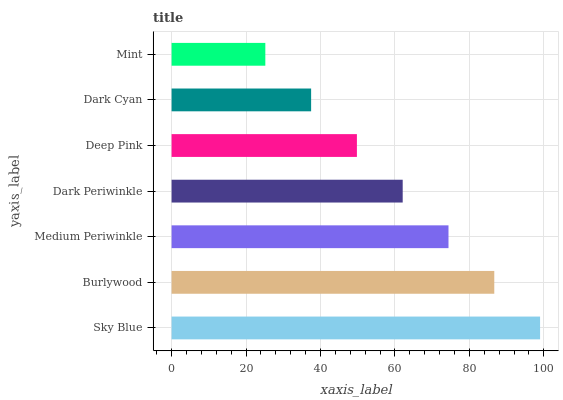Is Mint the minimum?
Answer yes or no. Yes. Is Sky Blue the maximum?
Answer yes or no. Yes. Is Burlywood the minimum?
Answer yes or no. No. Is Burlywood the maximum?
Answer yes or no. No. Is Sky Blue greater than Burlywood?
Answer yes or no. Yes. Is Burlywood less than Sky Blue?
Answer yes or no. Yes. Is Burlywood greater than Sky Blue?
Answer yes or no. No. Is Sky Blue less than Burlywood?
Answer yes or no. No. Is Dark Periwinkle the high median?
Answer yes or no. Yes. Is Dark Periwinkle the low median?
Answer yes or no. Yes. Is Sky Blue the high median?
Answer yes or no. No. Is Medium Periwinkle the low median?
Answer yes or no. No. 